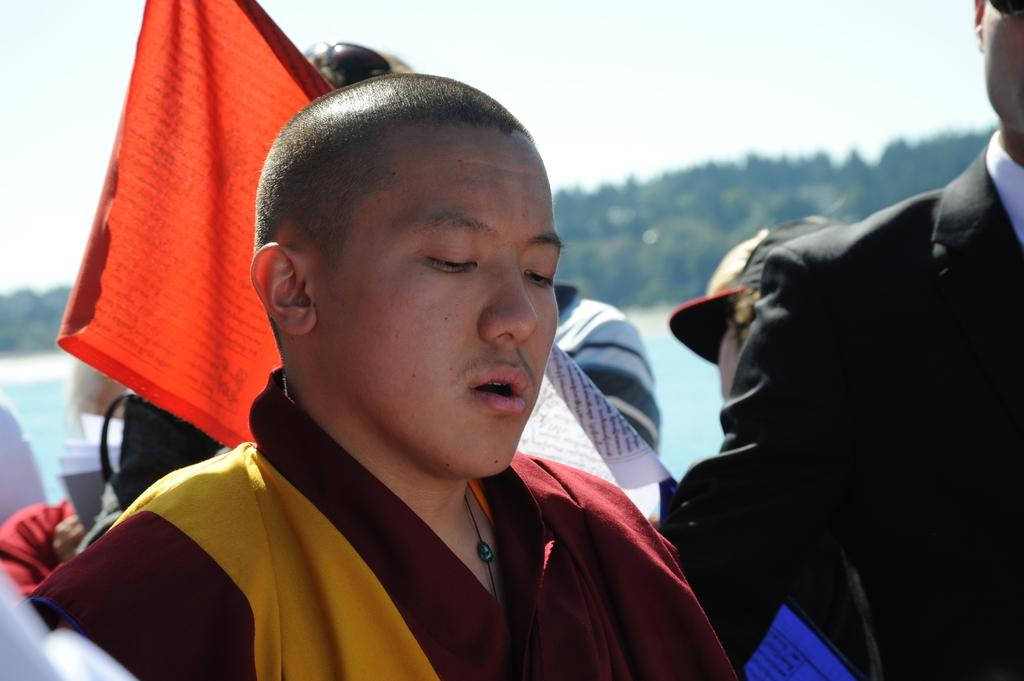What is happening in the image? There are people standing in the image. What can be seen besides the people in the image? There is a red color flag in the image. What type of flower is being used for educational purposes in the image? There is no flower or educational activity present in the image. 